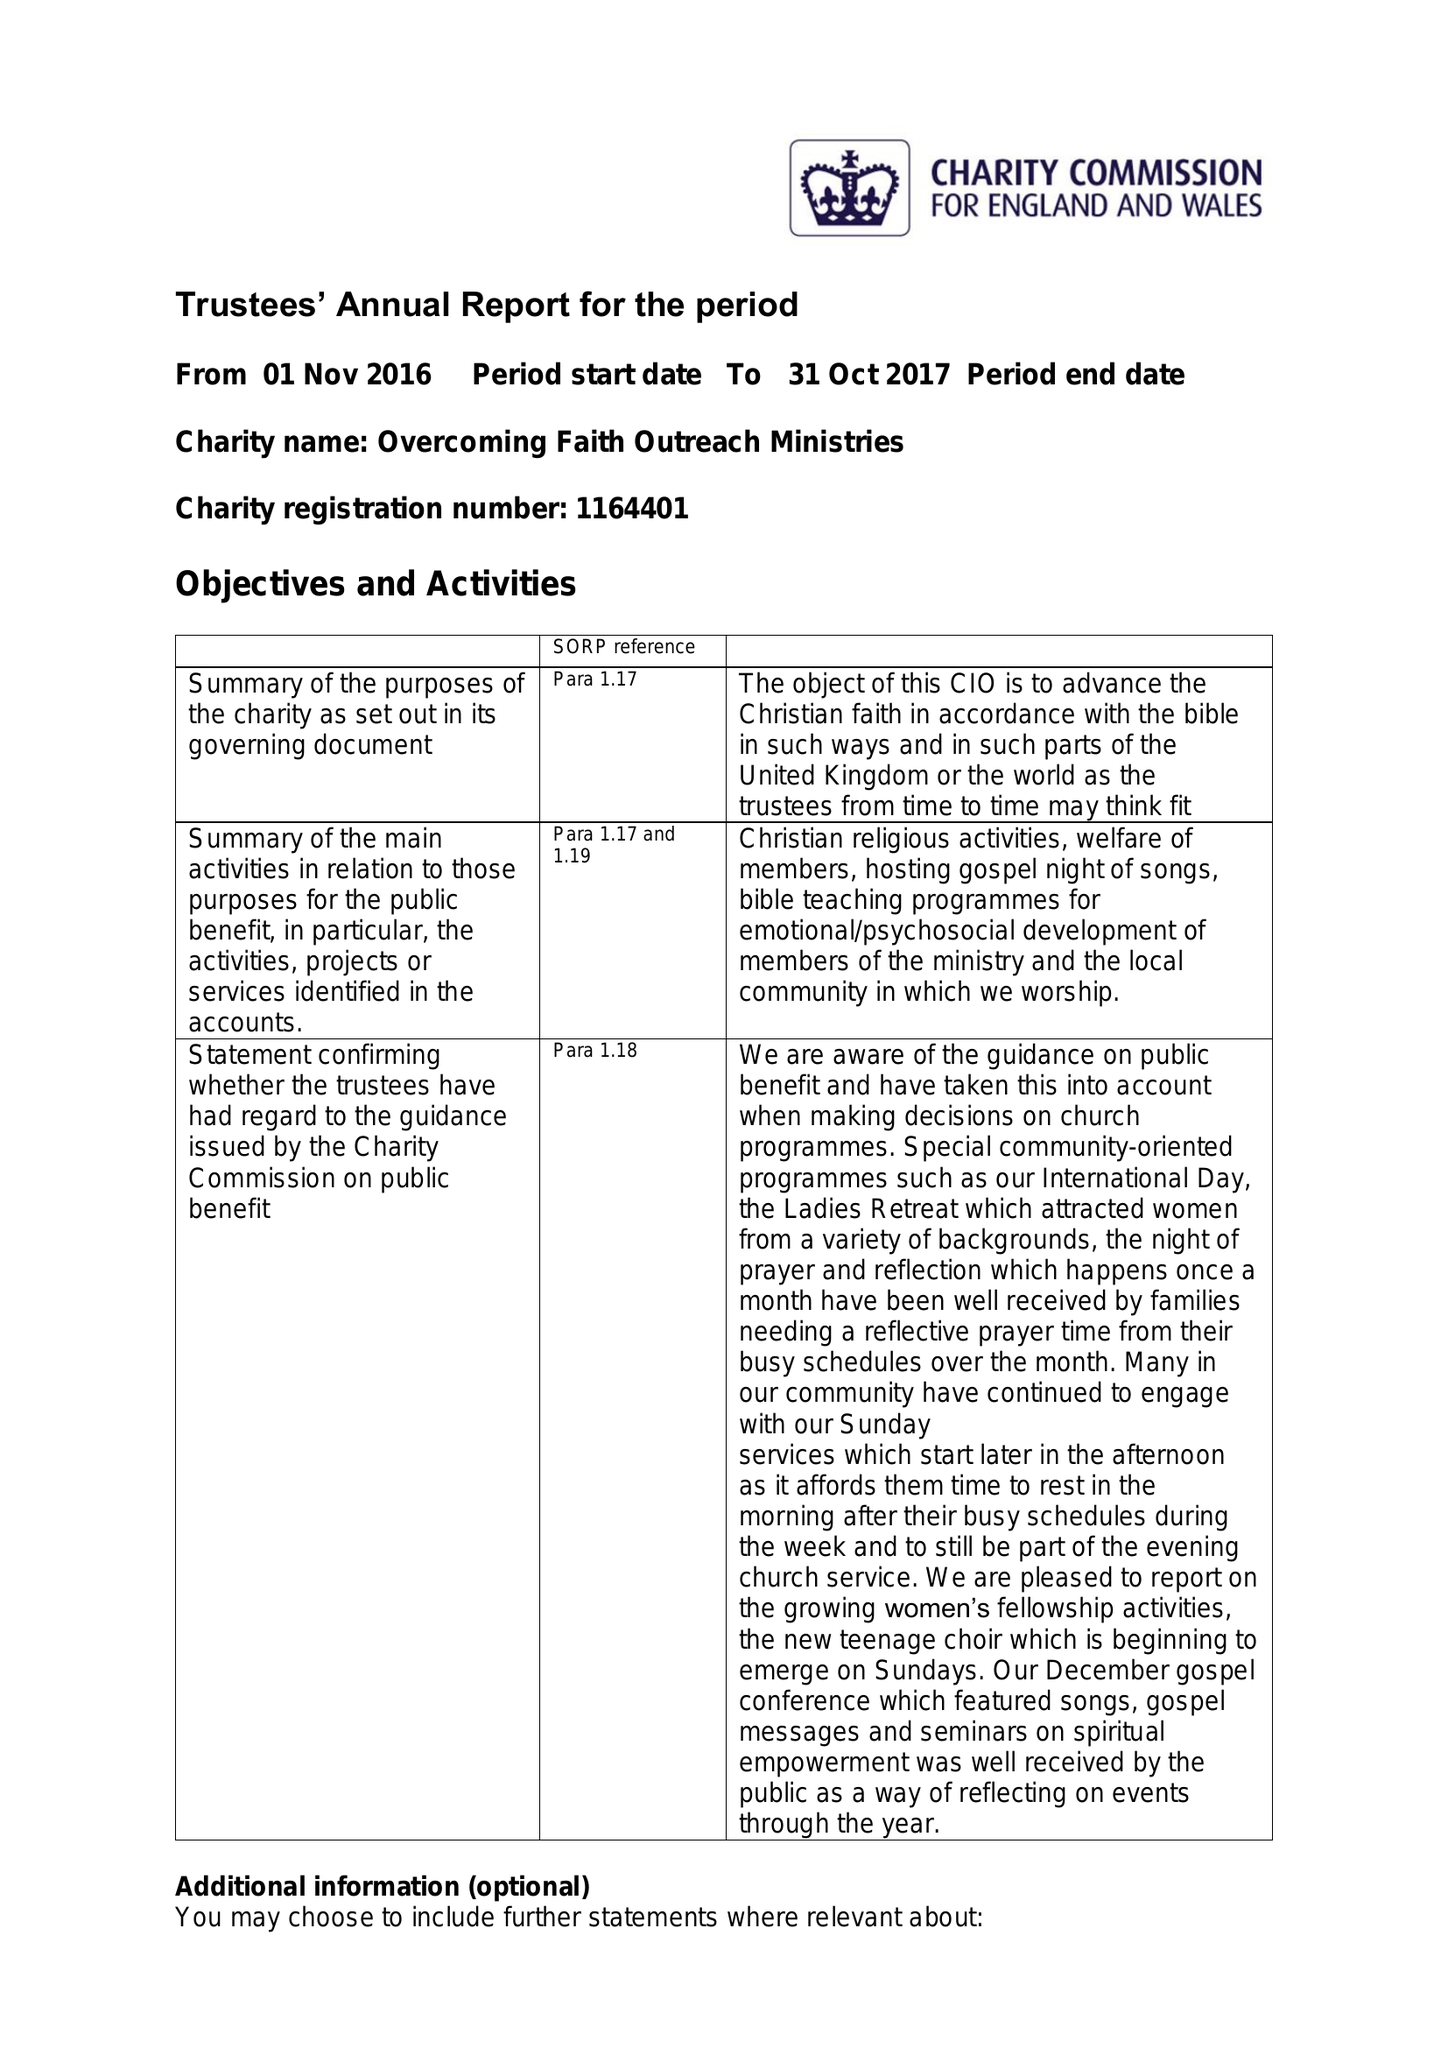What is the value for the address__postcode?
Answer the question using a single word or phrase. RM3 8YD 